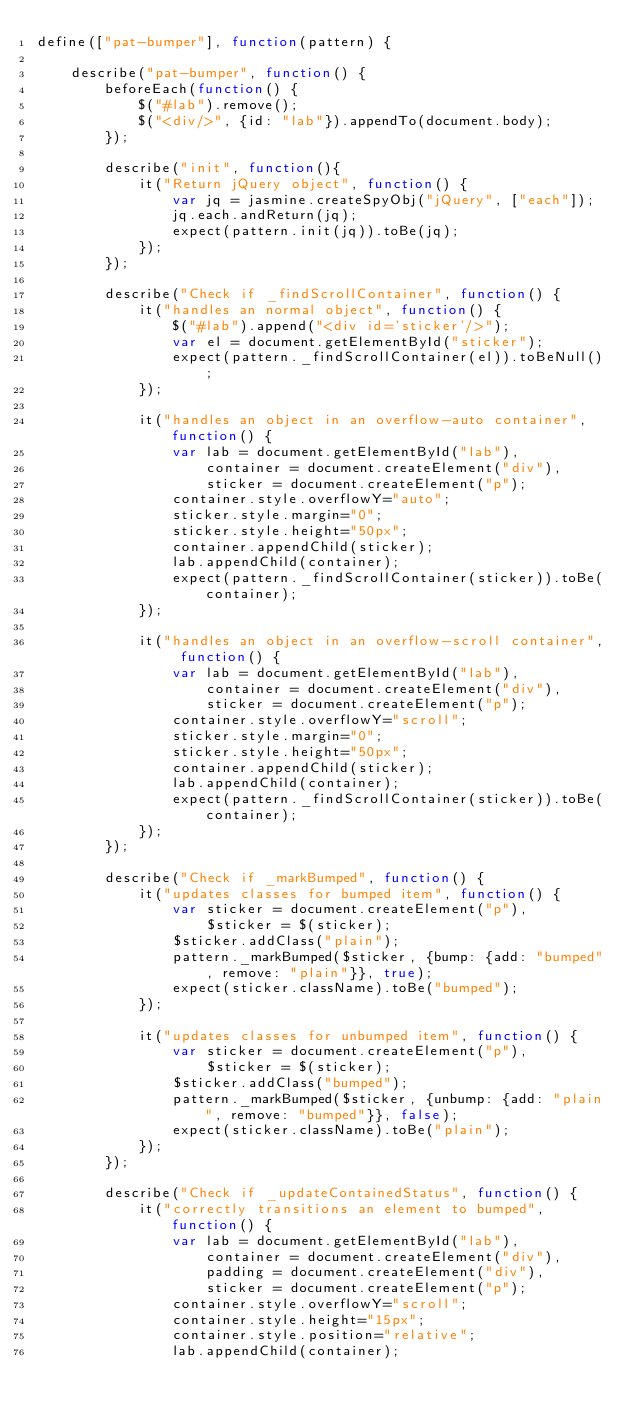Convert code to text. <code><loc_0><loc_0><loc_500><loc_500><_JavaScript_>define(["pat-bumper"], function(pattern) {

    describe("pat-bumper", function() {
        beforeEach(function() {
            $("#lab").remove();
            $("<div/>", {id: "lab"}).appendTo(document.body);
        });

        describe("init", function(){
            it("Return jQuery object", function() {
                var jq = jasmine.createSpyObj("jQuery", ["each"]);
                jq.each.andReturn(jq);
                expect(pattern.init(jq)).toBe(jq);
            });
        });

        describe("Check if _findScrollContainer", function() {
            it("handles an normal object", function() {
                $("#lab").append("<div id='sticker'/>");
                var el = document.getElementById("sticker");
                expect(pattern._findScrollContainer(el)).toBeNull();
            });

            it("handles an object in an overflow-auto container", function() {
                var lab = document.getElementById("lab"),
                    container = document.createElement("div"),
                    sticker = document.createElement("p");
                container.style.overflowY="auto";
                sticker.style.margin="0";
                sticker.style.height="50px";
                container.appendChild(sticker);
                lab.appendChild(container);
                expect(pattern._findScrollContainer(sticker)).toBe(container);
            });

            it("handles an object in an overflow-scroll container", function() {
                var lab = document.getElementById("lab"),
                    container = document.createElement("div"),
                    sticker = document.createElement("p");
                container.style.overflowY="scroll";
                sticker.style.margin="0";
                sticker.style.height="50px";
                container.appendChild(sticker);
                lab.appendChild(container);
                expect(pattern._findScrollContainer(sticker)).toBe(container);
            });
        });

        describe("Check if _markBumped", function() {
            it("updates classes for bumped item", function() {
                var sticker = document.createElement("p"),
                    $sticker = $(sticker);
                $sticker.addClass("plain");
                pattern._markBumped($sticker, {bump: {add: "bumped", remove: "plain"}}, true);
                expect(sticker.className).toBe("bumped");
            });

            it("updates classes for unbumped item", function() {
                var sticker = document.createElement("p"),
                    $sticker = $(sticker);
                $sticker.addClass("bumped");
                pattern._markBumped($sticker, {unbump: {add: "plain", remove: "bumped"}}, false);
                expect(sticker.className).toBe("plain");
            });
        });

        describe("Check if _updateContainedStatus", function() {
            it("correctly transitions an element to bumped", function() {
                var lab = document.getElementById("lab"),
                    container = document.createElement("div"),
                    padding = document.createElement("div"),
                    sticker = document.createElement("p");
                container.style.overflowY="scroll";
                container.style.height="15px";
                container.style.position="relative";
                lab.appendChild(container);</code> 